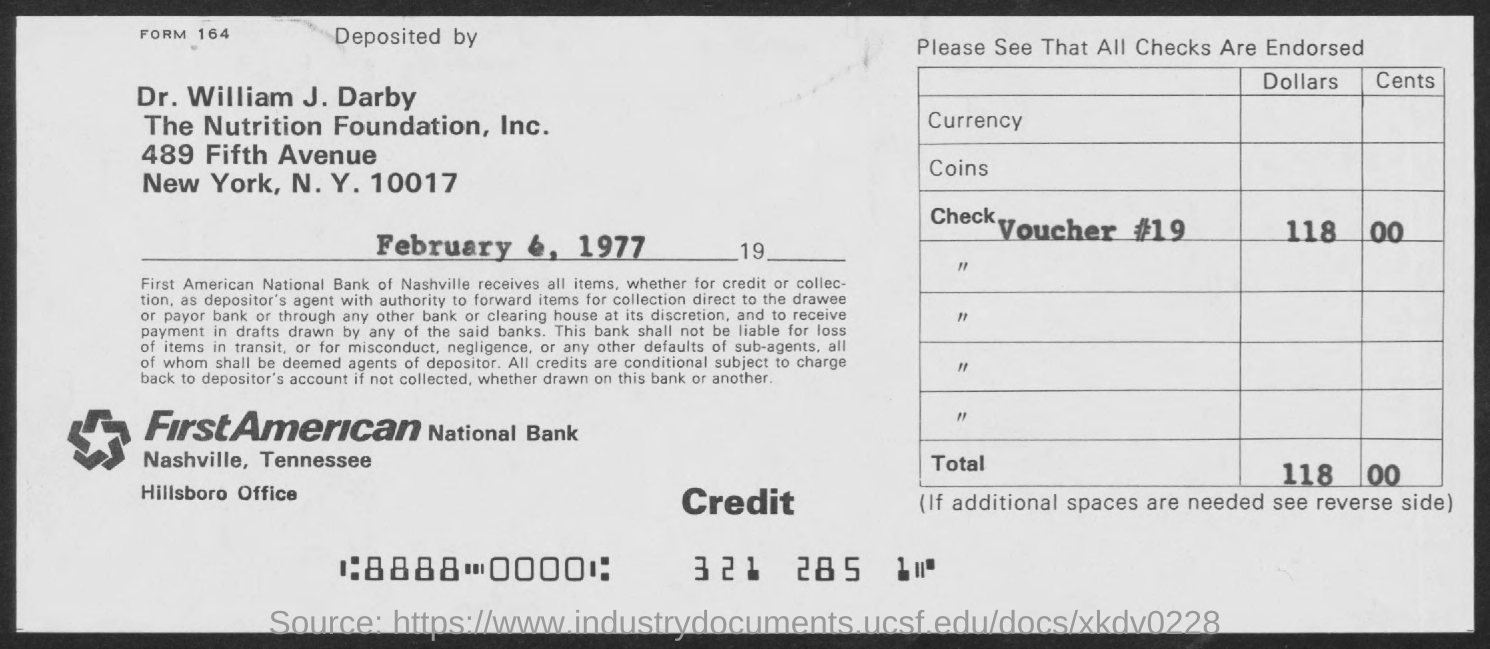What is the name of the bank?
Keep it short and to the point. First American National Bank. What is the address of first american national bank?
Keep it short and to the point. Nashville, Tennessee Hillsbore Office. What is the form no.?
Keep it short and to the point. 164. 